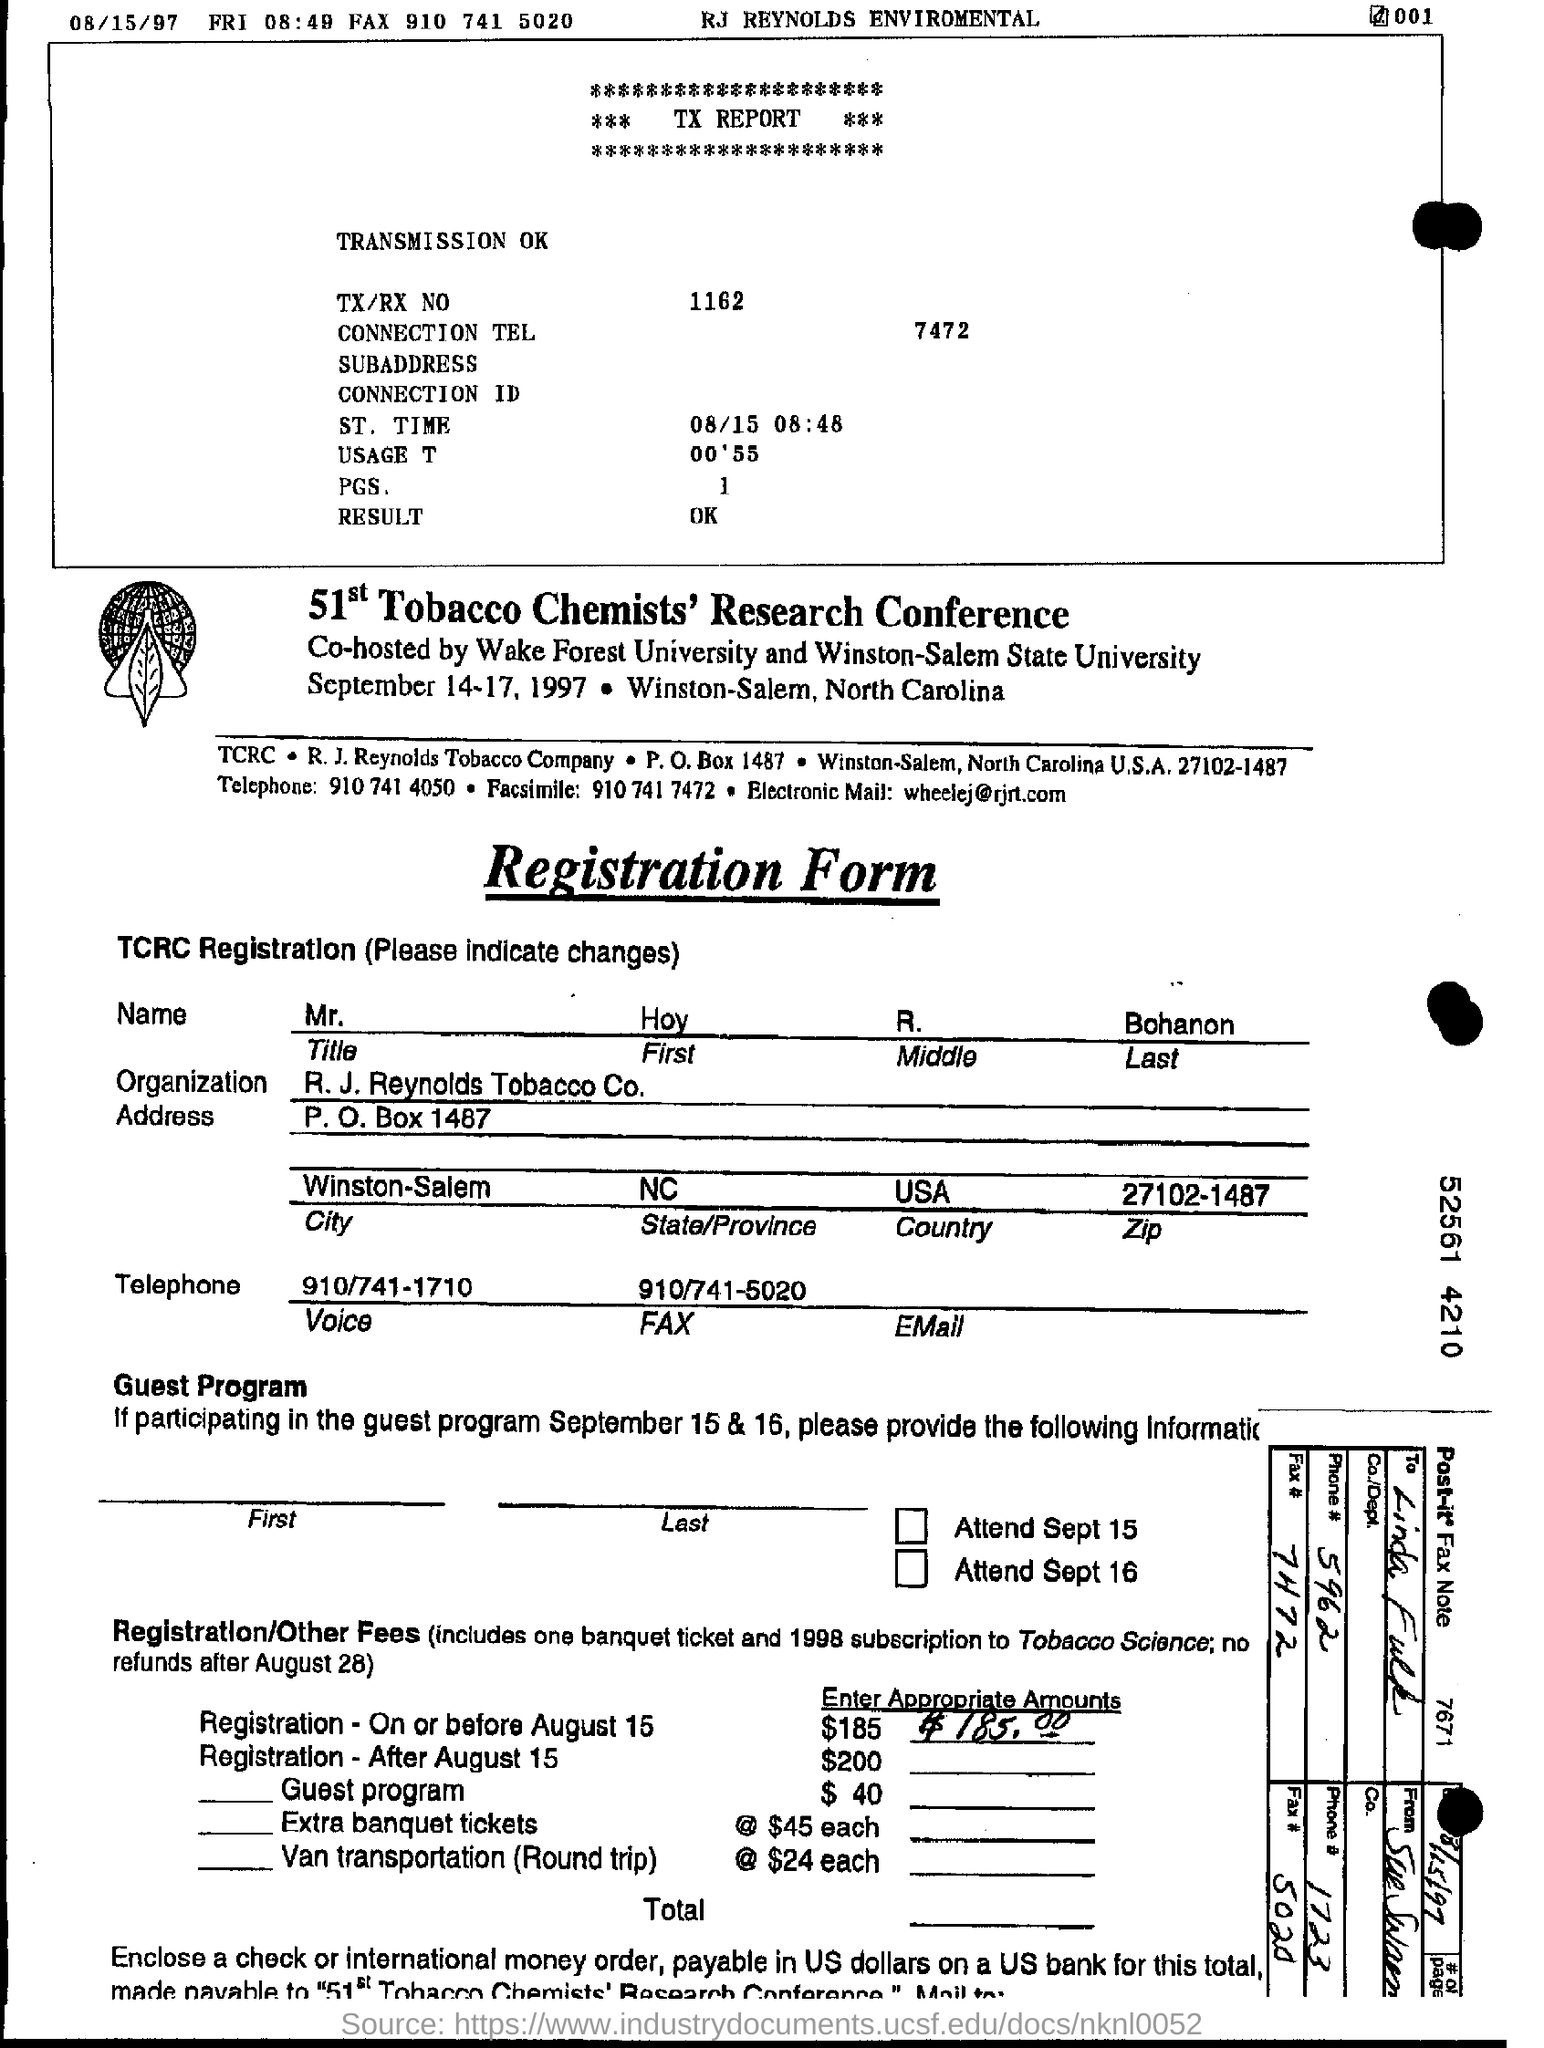What is the TX/RX No.?
Give a very brief answer. 1162. What is the Result?
Offer a terse response. OK. What is the Organization?
Offer a terse response. R. J. Reynolds Tobacco Co. What is the City?
Provide a succinct answer. Winston-Salem. What is the State/Province?
Make the answer very short. NC. What is the Zip?
Provide a succinct answer. 27102-1487. 